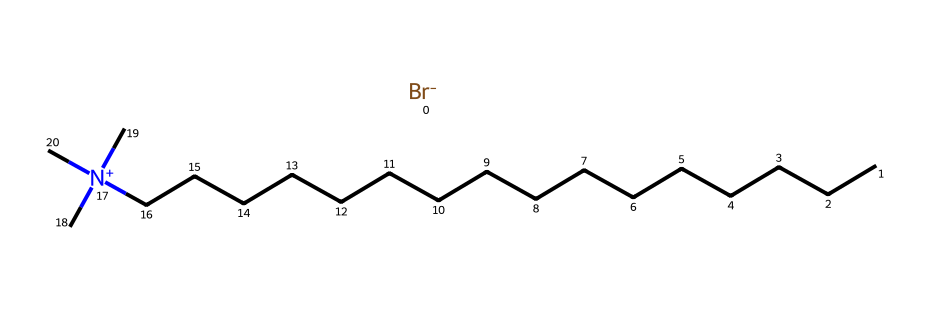What is the name of this chemical? The SMILES representation indicates the presence of a long hydrocarbon chain, a quaternary ammonium group, and a bromide ion. This combination corresponds to cetrimonium bromide, a well-known surfactant.
Answer: cetrimonium bromide How many carbon atoms are in this molecule? By analyzing the SMILES representation, the carbon atoms are part of the hydrocarbon chain "CCCCCCCCCCCCCCCC," which consists of 16 carbon atoms.
Answer: 16 What type of ion is present in this molecule? The presence of the "[Br-]" in the SMILES indicates a bromide ion, confirming that it is an anionic component of cetrimonium bromide.
Answer: bromide How many nitrogen atoms are present in this structure? The nitrogen atom is indicated by the "[N+](C)(C)C" part of the SMILES, which reveals there is one nitrogen atom in the molecule.
Answer: 1 What feature of cetrimonium bromide classifies it as a surfactant? Cetrimonium bromide contains a long hydrophobic hydrocarbon chain coupled with a cationic quaternary ammonium group, which provides both hydrophobic and hydrophilic characteristics, essential for surfactant properties.
Answer: hydrophobic and hydrophilic characteristics Is cetrimonium bromide a cationic or anionic surfactant? The presence of the quaternary ammonium structure "[N+]" makes cetrimonium bromide a cationic surfactant, as it carries a positive charge.
Answer: cationic 